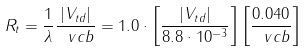<formula> <loc_0><loc_0><loc_500><loc_500>R _ { t } = \frac { 1 } { \lambda } \frac { | V _ { t d } | } { \ v c b } = 1 . 0 \cdot \left [ \frac { | V _ { t d } | } { 8 . 8 \cdot 1 0 ^ { - 3 } } \right ] \left [ \frac { 0 . 0 4 0 } { \ v c b } \right ]</formula> 